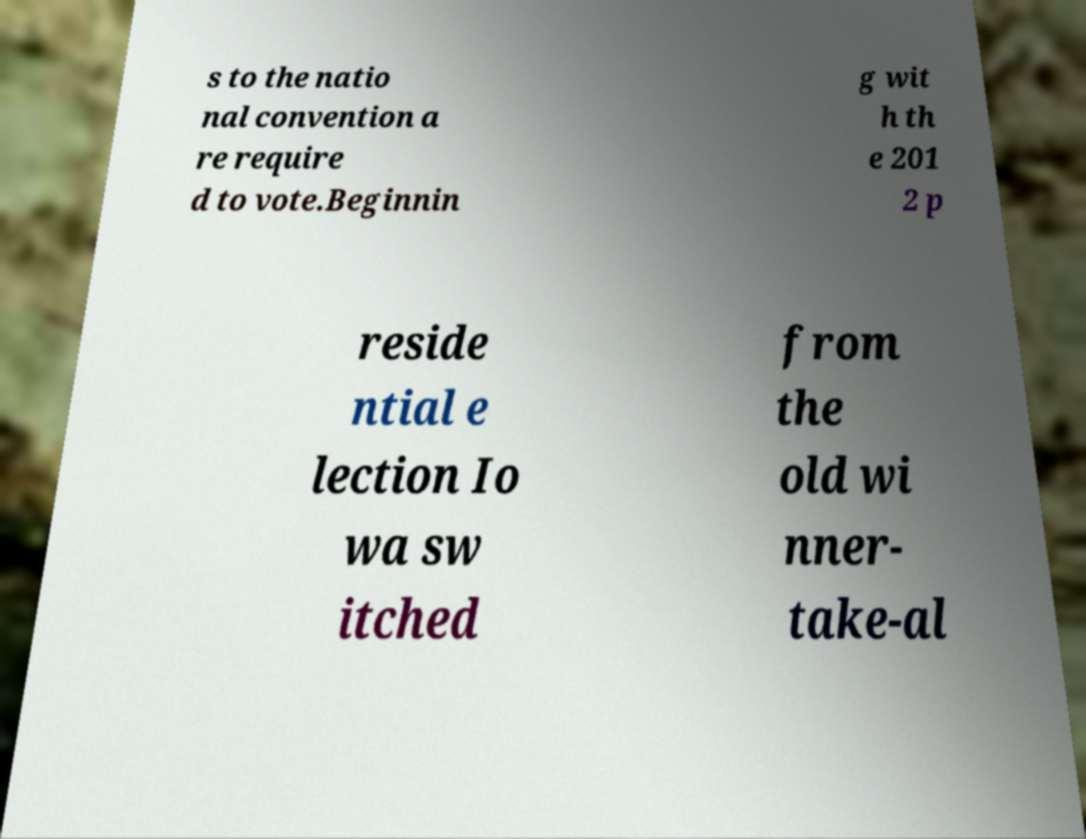For documentation purposes, I need the text within this image transcribed. Could you provide that? s to the natio nal convention a re require d to vote.Beginnin g wit h th e 201 2 p reside ntial e lection Io wa sw itched from the old wi nner- take-al 